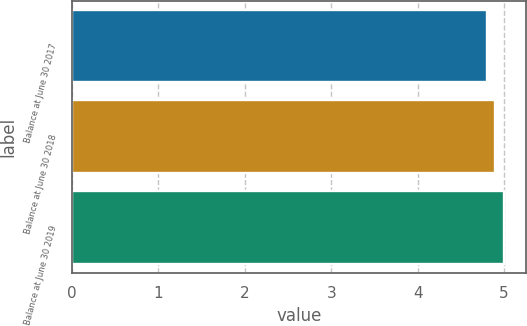<chart> <loc_0><loc_0><loc_500><loc_500><bar_chart><fcel>Balance at June 30 2017<fcel>Balance at June 30 2018<fcel>Balance at June 30 2019<nl><fcel>4.8<fcel>4.9<fcel>5<nl></chart> 